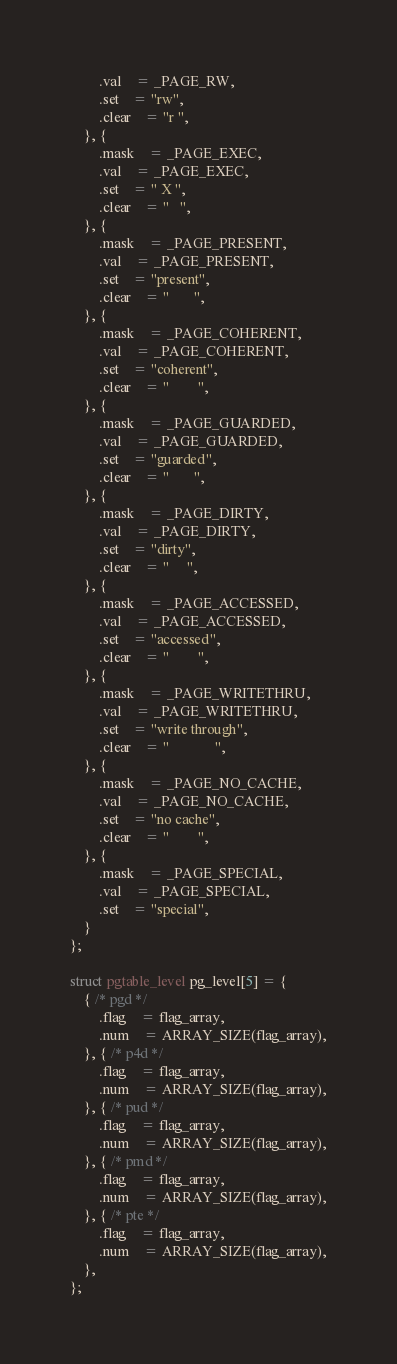Convert code to text. <code><loc_0><loc_0><loc_500><loc_500><_C_>		.val	= _PAGE_RW,
		.set	= "rw",
		.clear	= "r ",
	}, {
		.mask	= _PAGE_EXEC,
		.val	= _PAGE_EXEC,
		.set	= " X ",
		.clear	= "   ",
	}, {
		.mask	= _PAGE_PRESENT,
		.val	= _PAGE_PRESENT,
		.set	= "present",
		.clear	= "       ",
	}, {
		.mask	= _PAGE_COHERENT,
		.val	= _PAGE_COHERENT,
		.set	= "coherent",
		.clear	= "        ",
	}, {
		.mask	= _PAGE_GUARDED,
		.val	= _PAGE_GUARDED,
		.set	= "guarded",
		.clear	= "       ",
	}, {
		.mask	= _PAGE_DIRTY,
		.val	= _PAGE_DIRTY,
		.set	= "dirty",
		.clear	= "     ",
	}, {
		.mask	= _PAGE_ACCESSED,
		.val	= _PAGE_ACCESSED,
		.set	= "accessed",
		.clear	= "        ",
	}, {
		.mask	= _PAGE_WRITETHRU,
		.val	= _PAGE_WRITETHRU,
		.set	= "write through",
		.clear	= "             ",
	}, {
		.mask	= _PAGE_NO_CACHE,
		.val	= _PAGE_NO_CACHE,
		.set	= "no cache",
		.clear	= "        ",
	}, {
		.mask	= _PAGE_SPECIAL,
		.val	= _PAGE_SPECIAL,
		.set	= "special",
	}
};

struct pgtable_level pg_level[5] = {
	{ /* pgd */
		.flag	= flag_array,
		.num	= ARRAY_SIZE(flag_array),
	}, { /* p4d */
		.flag	= flag_array,
		.num	= ARRAY_SIZE(flag_array),
	}, { /* pud */
		.flag	= flag_array,
		.num	= ARRAY_SIZE(flag_array),
	}, { /* pmd */
		.flag	= flag_array,
		.num	= ARRAY_SIZE(flag_array),
	}, { /* pte */
		.flag	= flag_array,
		.num	= ARRAY_SIZE(flag_array),
	},
};
</code> 